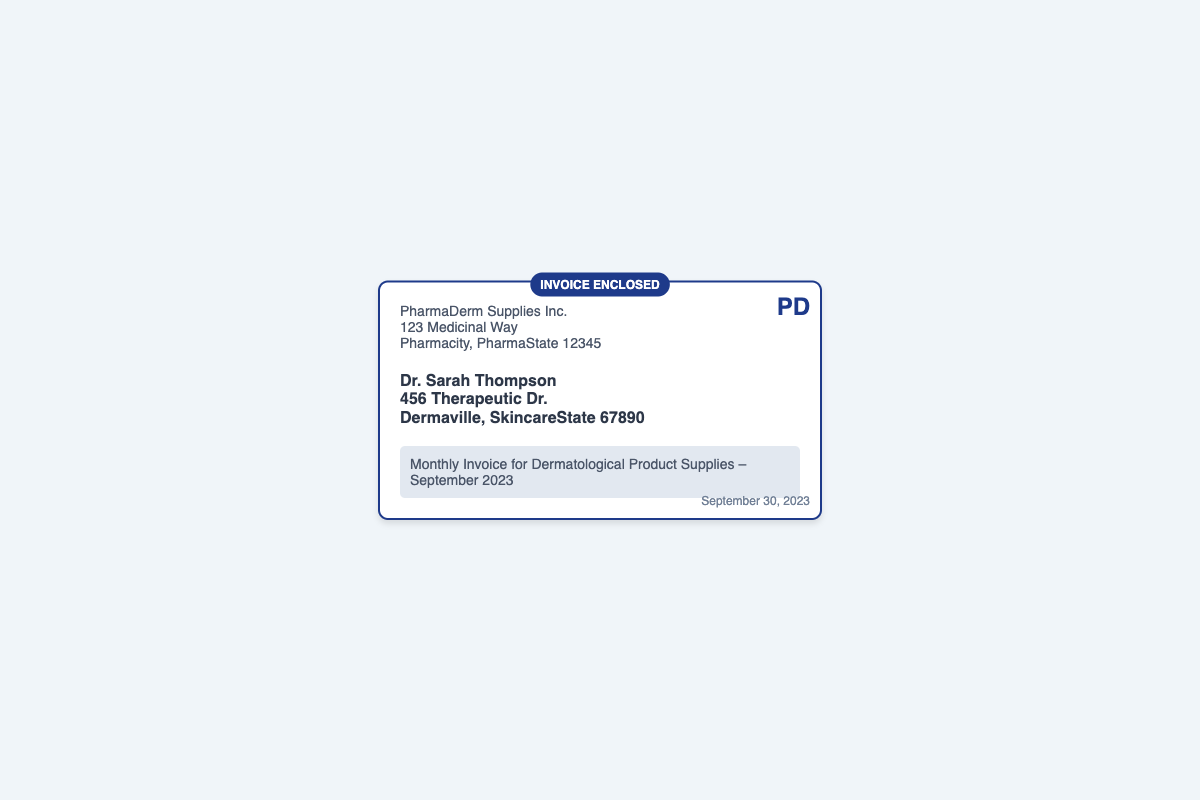What is the name of the sender? The sender's name is listed at the top left of the document.
Answer: PharmaDerm Supplies Inc Who is the recipient of the invoice? The recipient's name is stated below the sender's information.
Answer: Dr. Sarah Thompson What is the subject of the invoice? The subject line indicates what the document is about.
Answer: Monthly Invoice for Dermatological Product Supplies – September 2023 What is the date on the document? The date is located at the bottom right corner of the envelope.
Answer: September 30, 2023 Where is the sender located? The sender's address is included in the sender's information section.
Answer: 123 Medicinal Way, Pharmacity, PharmaState 12345 What type of document is this? The type of document is indicated in the subject line.
Answer: Invoice What color is the envelope's border? The color of the envelope's border can be seen in its design.
Answer: Dark blue What is the font style used in the envelope? The font style for the text is mentioned in the styling section of the document.
Answer: Helvetica What is the keyword highlighted on the envelope? The highlighted keyword indicates the purpose of the document.
Answer: INVOICE ENCLOSED 